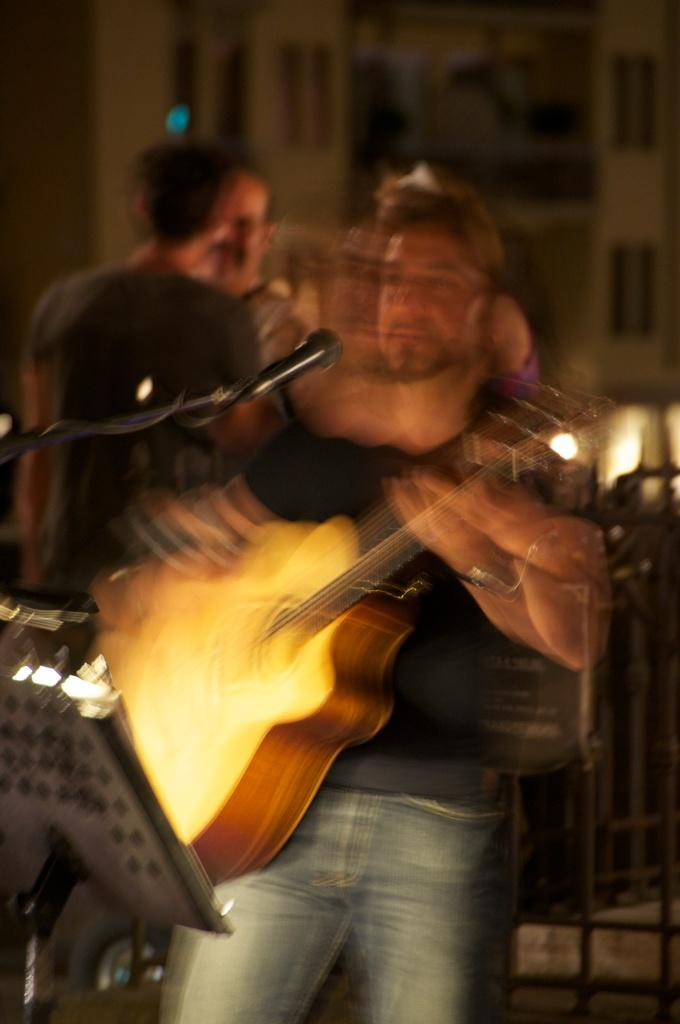How many people are in the image? There are three persons in the image. What is the man holding in his hand? The man is holding a guitar in his hand. What object is in front of the man? There is a microphone in front of the man. Can you describe the other two persons in the image? There are two other persons standing in the background. What type of vacation is the man planning based on the image? There is no information about a vacation in the image. Can you hear the man laughing in the image? The image is a still picture and does not contain any sound, so we cannot hear the man laughing. 